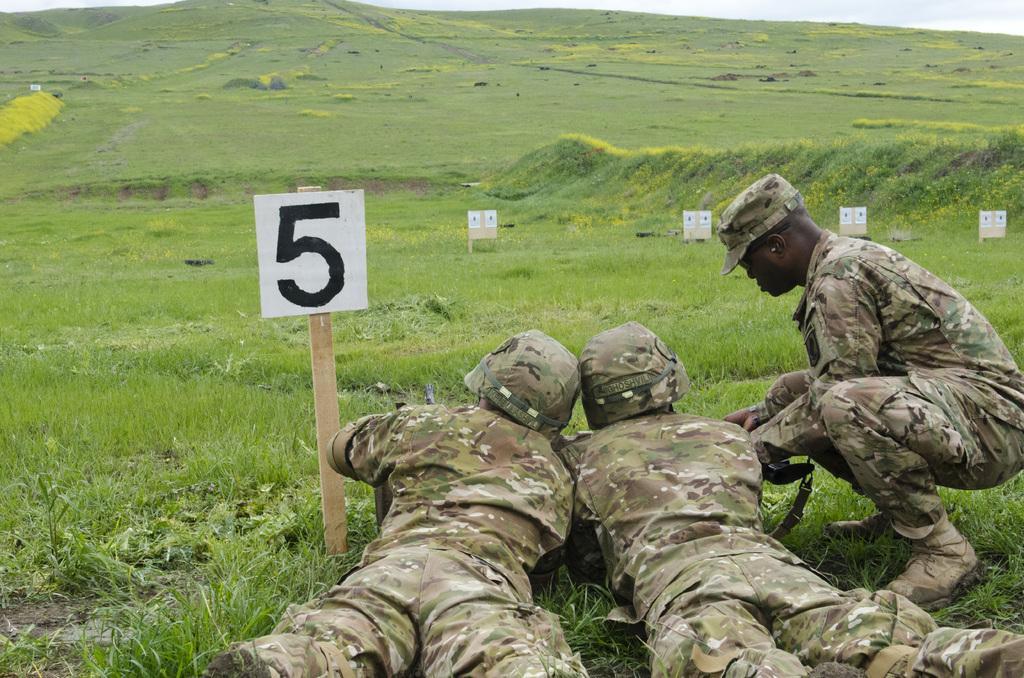How would you summarize this image in a sentence or two? There are three persons wearing caps. Two are lying on the ground. And one person in couch position. On the ground there is grass. Also there is a placard with number. In the back there are boards. 